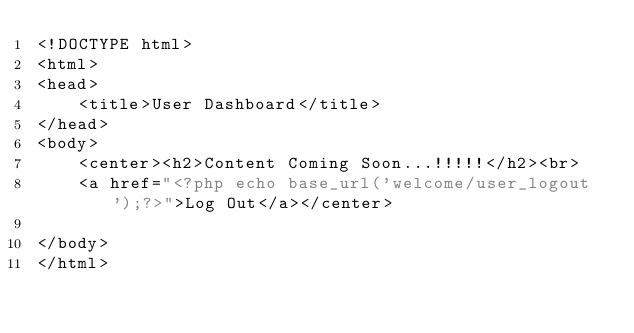Convert code to text. <code><loc_0><loc_0><loc_500><loc_500><_PHP_><!DOCTYPE html>
<html>
<head>
	<title>User Dashboard</title>
</head>
<body>
	<center><h2>Content Coming Soon...!!!!!</h2><br>
	<a href="<?php echo base_url('welcome/user_logout');?>">Log Out</a></center>

</body>
</html></code> 